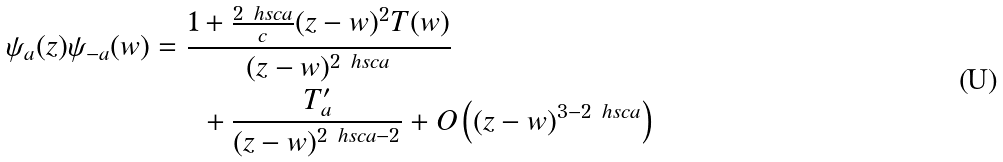Convert formula to latex. <formula><loc_0><loc_0><loc_500><loc_500>\psi _ { a } ( z ) \psi _ { - a } ( w ) & = \frac { 1 + \frac { 2 \ h s c a } { c } ( z - w ) ^ { 2 } T ( w ) } { ( z - w ) ^ { 2 \ h s c a } } \\ & \quad \ \ + \frac { T ^ { \prime } _ { a } } { ( z - w ) ^ { 2 \ h s c a - 2 } } + O \left ( ( z - w ) ^ { 3 - 2 \ h s c a } \right )</formula> 